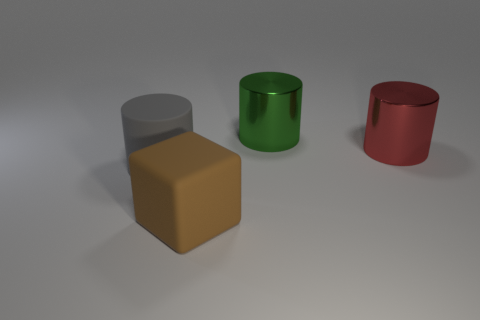What textures do the surfaces of the objects seem to show? The surfaces of the objects appear smooth and matte. There's no reflection or glossy sheen, which implies that the materials could be non-reflective, possibly like a rubber or a soft plastic.  Can you speculate on what these objects might be used for based on their shapes and sizes? Based on their simple geometric shapes and uniform colors, these objects may be used as teaching tools or elements in a visual aid, designed to help people learn about shapes, dimensions, and spatial relationships. They could also be part of a designer's 3D modeling toolkit for creating and testing virtual environments. 